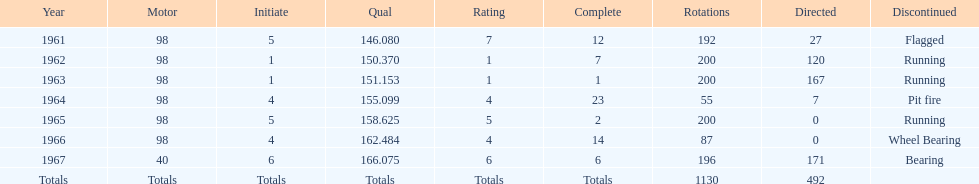I'm looking to parse the entire table for insights. Could you assist me with that? {'header': ['Year', 'Motor', 'Initiate', 'Qual', 'Rating', 'Complete', 'Rotations', 'Directed', 'Discontinued'], 'rows': [['1961', '98', '5', '146.080', '7', '12', '192', '27', 'Flagged'], ['1962', '98', '1', '150.370', '1', '7', '200', '120', 'Running'], ['1963', '98', '1', '151.153', '1', '1', '200', '167', 'Running'], ['1964', '98', '4', '155.099', '4', '23', '55', '7', 'Pit fire'], ['1965', '98', '5', '158.625', '5', '2', '200', '0', 'Running'], ['1966', '98', '4', '162.484', '4', '14', '87', '0', 'Wheel Bearing'], ['1967', '40', '6', '166.075', '6', '6', '196', '171', 'Bearing'], ['Totals', 'Totals', 'Totals', 'Totals', 'Totals', 'Totals', '1130', '492', '']]} Previous to 1965, when did jones have a number 5 start at the indy 500? 1961. 